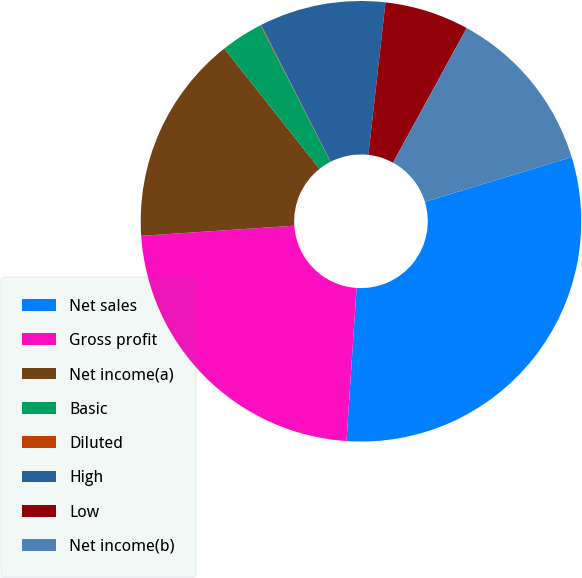Convert chart. <chart><loc_0><loc_0><loc_500><loc_500><pie_chart><fcel>Net sales<fcel>Gross profit<fcel>Net income(a)<fcel>Basic<fcel>Diluted<fcel>High<fcel>Low<fcel>Net income(b)<nl><fcel>30.75%<fcel>22.9%<fcel>15.4%<fcel>3.12%<fcel>0.05%<fcel>9.26%<fcel>6.19%<fcel>12.33%<nl></chart> 